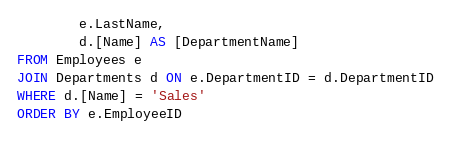Convert code to text. <code><loc_0><loc_0><loc_500><loc_500><_SQL_>		e.LastName,
		d.[Name] AS [DepartmentName]
FROM Employees e
JOIN Departments d ON e.DepartmentID = d.DepartmentID
WHERE d.[Name] = 'Sales'
ORDER BY e.EmployeeID</code> 